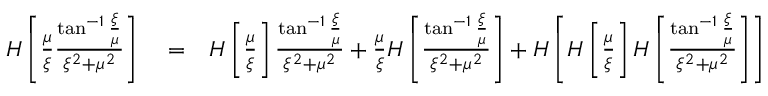<formula> <loc_0><loc_0><loc_500><loc_500>\begin{array} { r l r } { H \left [ \frac { \mu } { \xi } \frac { \tan ^ { - 1 } \frac { \xi } { \mu } } { \xi ^ { 2 } + \mu ^ { 2 } } \right ] } & = } & { H \left [ \frac { \mu } { \xi } \right ] \frac { \tan ^ { - 1 } \frac { \xi } { \mu } } { \xi ^ { 2 } + \mu ^ { 2 } } + \frac { \mu } { \xi } H \left [ \frac { \tan ^ { - 1 } \frac { \xi } { \mu } } { \xi ^ { 2 } + \mu ^ { 2 } } \right ] + H \left [ H \left [ \frac { \mu } { \xi } \right ] H \left [ \frac { \tan ^ { - 1 } \frac { \xi } { \mu } } { \xi ^ { 2 } + \mu ^ { 2 } } \right ] \right ] } \end{array}</formula> 